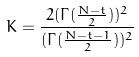<formula> <loc_0><loc_0><loc_500><loc_500>K = \frac { 2 ( \Gamma ( \frac { N - t } { 2 } ) ) ^ { 2 } } { ( \Gamma ( \frac { N - t - 1 } { 2 } ) ) ^ { 2 } }</formula> 